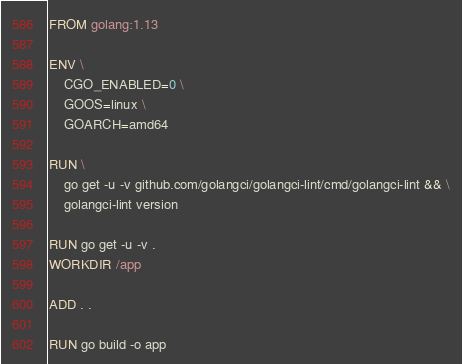<code> <loc_0><loc_0><loc_500><loc_500><_Dockerfile_>FROM golang:1.13

ENV \
    CGO_ENABLED=0 \
    GOOS=linux \
    GOARCH=amd64

RUN \
    go get -u -v github.com/golangci/golangci-lint/cmd/golangci-lint && \
    golangci-lint version

RUN go get -u -v .
WORKDIR /app

ADD . .

RUN go build -o app
</code> 